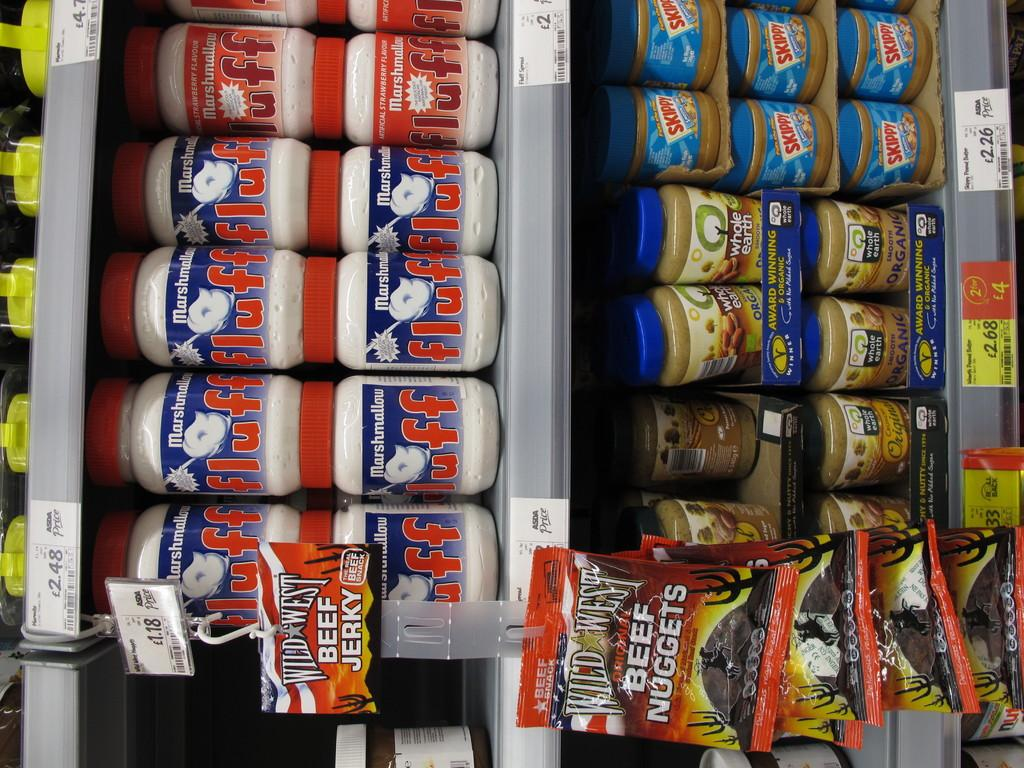<image>
Summarize the visual content of the image. Snack products like beef jerky and Skippy peanut butter are shown with prices for sale on grocery shelves. 